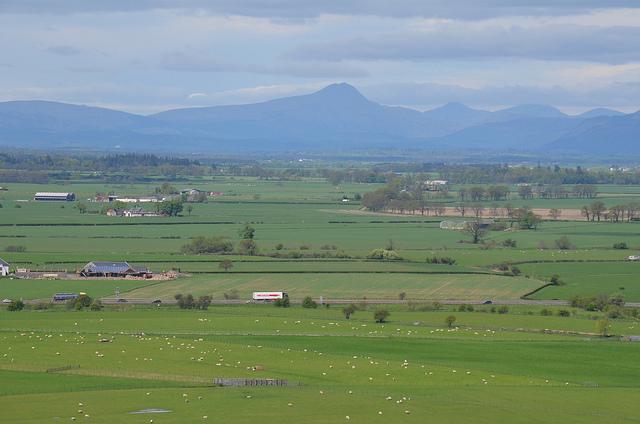Are there mountains in the background?
Write a very short answer. Yes. What kind of clouds are in the sky?
Answer briefly. Cumulus. Is there grass in the photo?
Give a very brief answer. Yes. 